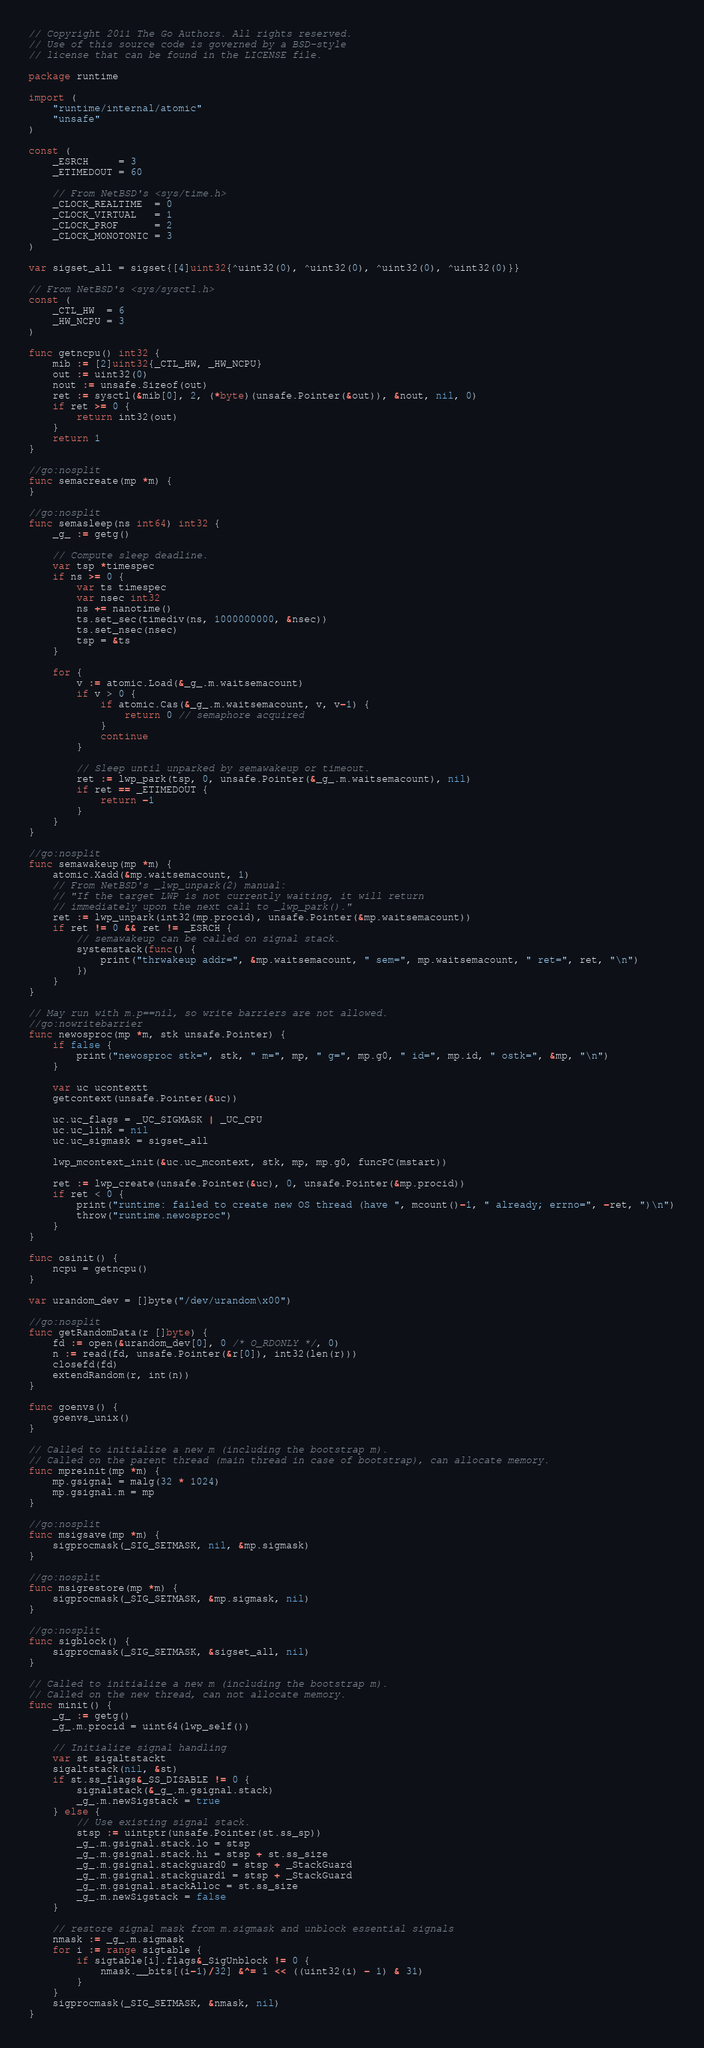Convert code to text. <code><loc_0><loc_0><loc_500><loc_500><_Go_>// Copyright 2011 The Go Authors. All rights reserved.
// Use of this source code is governed by a BSD-style
// license that can be found in the LICENSE file.

package runtime

import (
	"runtime/internal/atomic"
	"unsafe"
)

const (
	_ESRCH     = 3
	_ETIMEDOUT = 60

	// From NetBSD's <sys/time.h>
	_CLOCK_REALTIME  = 0
	_CLOCK_VIRTUAL   = 1
	_CLOCK_PROF      = 2
	_CLOCK_MONOTONIC = 3
)

var sigset_all = sigset{[4]uint32{^uint32(0), ^uint32(0), ^uint32(0), ^uint32(0)}}

// From NetBSD's <sys/sysctl.h>
const (
	_CTL_HW  = 6
	_HW_NCPU = 3
)

func getncpu() int32 {
	mib := [2]uint32{_CTL_HW, _HW_NCPU}
	out := uint32(0)
	nout := unsafe.Sizeof(out)
	ret := sysctl(&mib[0], 2, (*byte)(unsafe.Pointer(&out)), &nout, nil, 0)
	if ret >= 0 {
		return int32(out)
	}
	return 1
}

//go:nosplit
func semacreate(mp *m) {
}

//go:nosplit
func semasleep(ns int64) int32 {
	_g_ := getg()

	// Compute sleep deadline.
	var tsp *timespec
	if ns >= 0 {
		var ts timespec
		var nsec int32
		ns += nanotime()
		ts.set_sec(timediv(ns, 1000000000, &nsec))
		ts.set_nsec(nsec)
		tsp = &ts
	}

	for {
		v := atomic.Load(&_g_.m.waitsemacount)
		if v > 0 {
			if atomic.Cas(&_g_.m.waitsemacount, v, v-1) {
				return 0 // semaphore acquired
			}
			continue
		}

		// Sleep until unparked by semawakeup or timeout.
		ret := lwp_park(tsp, 0, unsafe.Pointer(&_g_.m.waitsemacount), nil)
		if ret == _ETIMEDOUT {
			return -1
		}
	}
}

//go:nosplit
func semawakeup(mp *m) {
	atomic.Xadd(&mp.waitsemacount, 1)
	// From NetBSD's _lwp_unpark(2) manual:
	// "If the target LWP is not currently waiting, it will return
	// immediately upon the next call to _lwp_park()."
	ret := lwp_unpark(int32(mp.procid), unsafe.Pointer(&mp.waitsemacount))
	if ret != 0 && ret != _ESRCH {
		// semawakeup can be called on signal stack.
		systemstack(func() {
			print("thrwakeup addr=", &mp.waitsemacount, " sem=", mp.waitsemacount, " ret=", ret, "\n")
		})
	}
}

// May run with m.p==nil, so write barriers are not allowed.
//go:nowritebarrier
func newosproc(mp *m, stk unsafe.Pointer) {
	if false {
		print("newosproc stk=", stk, " m=", mp, " g=", mp.g0, " id=", mp.id, " ostk=", &mp, "\n")
	}

	var uc ucontextt
	getcontext(unsafe.Pointer(&uc))

	uc.uc_flags = _UC_SIGMASK | _UC_CPU
	uc.uc_link = nil
	uc.uc_sigmask = sigset_all

	lwp_mcontext_init(&uc.uc_mcontext, stk, mp, mp.g0, funcPC(mstart))

	ret := lwp_create(unsafe.Pointer(&uc), 0, unsafe.Pointer(&mp.procid))
	if ret < 0 {
		print("runtime: failed to create new OS thread (have ", mcount()-1, " already; errno=", -ret, ")\n")
		throw("runtime.newosproc")
	}
}

func osinit() {
	ncpu = getncpu()
}

var urandom_dev = []byte("/dev/urandom\x00")

//go:nosplit
func getRandomData(r []byte) {
	fd := open(&urandom_dev[0], 0 /* O_RDONLY */, 0)
	n := read(fd, unsafe.Pointer(&r[0]), int32(len(r)))
	closefd(fd)
	extendRandom(r, int(n))
}

func goenvs() {
	goenvs_unix()
}

// Called to initialize a new m (including the bootstrap m).
// Called on the parent thread (main thread in case of bootstrap), can allocate memory.
func mpreinit(mp *m) {
	mp.gsignal = malg(32 * 1024)
	mp.gsignal.m = mp
}

//go:nosplit
func msigsave(mp *m) {
	sigprocmask(_SIG_SETMASK, nil, &mp.sigmask)
}

//go:nosplit
func msigrestore(mp *m) {
	sigprocmask(_SIG_SETMASK, &mp.sigmask, nil)
}

//go:nosplit
func sigblock() {
	sigprocmask(_SIG_SETMASK, &sigset_all, nil)
}

// Called to initialize a new m (including the bootstrap m).
// Called on the new thread, can not allocate memory.
func minit() {
	_g_ := getg()
	_g_.m.procid = uint64(lwp_self())

	// Initialize signal handling
	var st sigaltstackt
	sigaltstack(nil, &st)
	if st.ss_flags&_SS_DISABLE != 0 {
		signalstack(&_g_.m.gsignal.stack)
		_g_.m.newSigstack = true
	} else {
		// Use existing signal stack.
		stsp := uintptr(unsafe.Pointer(st.ss_sp))
		_g_.m.gsignal.stack.lo = stsp
		_g_.m.gsignal.stack.hi = stsp + st.ss_size
		_g_.m.gsignal.stackguard0 = stsp + _StackGuard
		_g_.m.gsignal.stackguard1 = stsp + _StackGuard
		_g_.m.gsignal.stackAlloc = st.ss_size
		_g_.m.newSigstack = false
	}

	// restore signal mask from m.sigmask and unblock essential signals
	nmask := _g_.m.sigmask
	for i := range sigtable {
		if sigtable[i].flags&_SigUnblock != 0 {
			nmask.__bits[(i-1)/32] &^= 1 << ((uint32(i) - 1) & 31)
		}
	}
	sigprocmask(_SIG_SETMASK, &nmask, nil)
}
</code> 